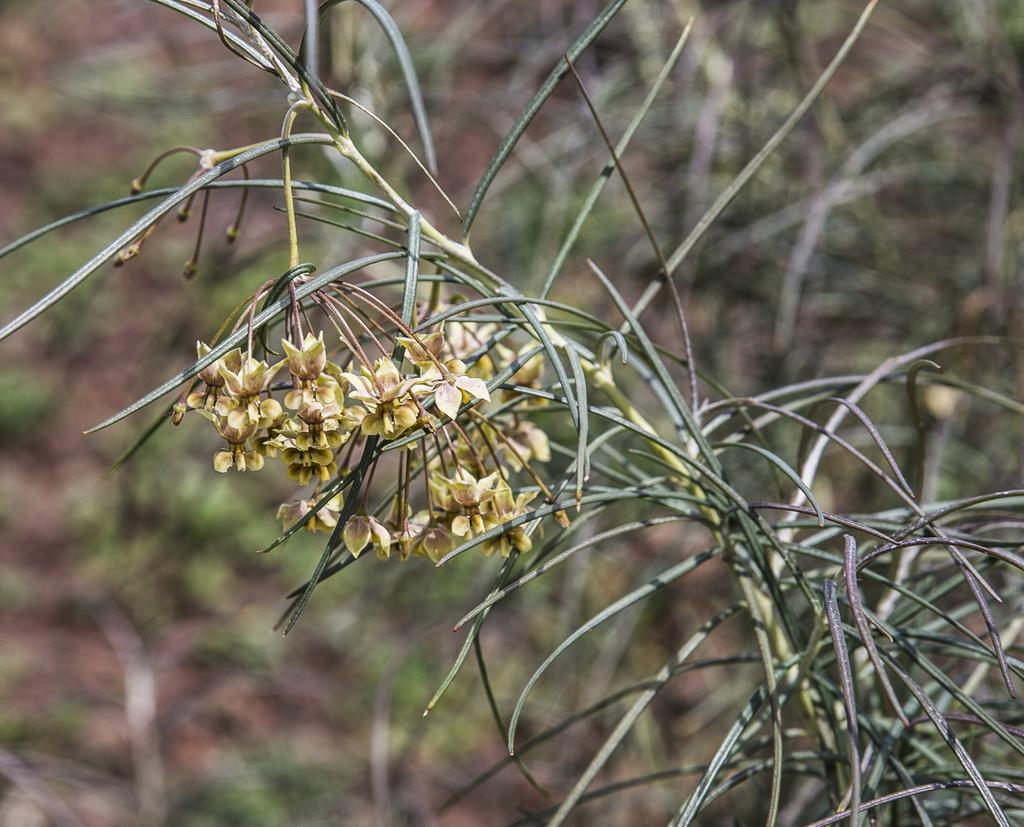What is the main subject of the image? The main subject of the image is a plant with many flowers. Can you describe the background of the image? The background of the image is blurred. How many bricks are stacked on the truck in the image? There is no truck or bricks present in the image; it features a plant with many flowers and a blurred background. Can you see an owl perched on the plant in the image? There is no owl present in the image; it features a plant with many flowers and a blurred background. 